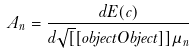Convert formula to latex. <formula><loc_0><loc_0><loc_500><loc_500>A _ { n } = { \frac { d E ( c ) } { d { \sqrt { [ } [ o b j e c t O b j e c t ] ] { \mu _ { n } } } } }</formula> 